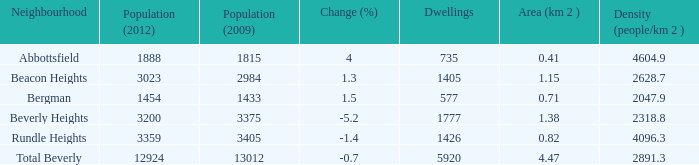Can you give me this table as a dict? {'header': ['Neighbourhood', 'Population (2012)', 'Population (2009)', 'Change (%)', 'Dwellings', 'Area (km 2 )', 'Density (people/km 2 )'], 'rows': [['Abbottsfield', '1888', '1815', '4', '735', '0.41', '4604.9'], ['Beacon Heights', '3023', '2984', '1.3', '1405', '1.15', '2628.7'], ['Bergman', '1454', '1433', '1.5', '577', '0.71', '2047.9'], ['Beverly Heights', '3200', '3375', '-5.2', '1777', '1.38', '2318.8'], ['Rundle Heights', '3359', '3405', '-1.4', '1426', '0.82', '4096.3'], ['Total Beverly', '12924', '13012', '-0.7', '5920', '4.47', '2891.3']]} Calculate the density for an area of 1.38 km with a population greater than 12,924. 0.0. 